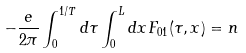<formula> <loc_0><loc_0><loc_500><loc_500>- \frac { e } { 2 \pi } \int _ { 0 } ^ { 1 / T } d \tau \int _ { 0 } ^ { L } d x F _ { 0 1 } ( \tau , x ) = n</formula> 